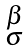Convert formula to latex. <formula><loc_0><loc_0><loc_500><loc_500>\begin{smallmatrix} \beta \\ \sigma \end{smallmatrix}</formula> 